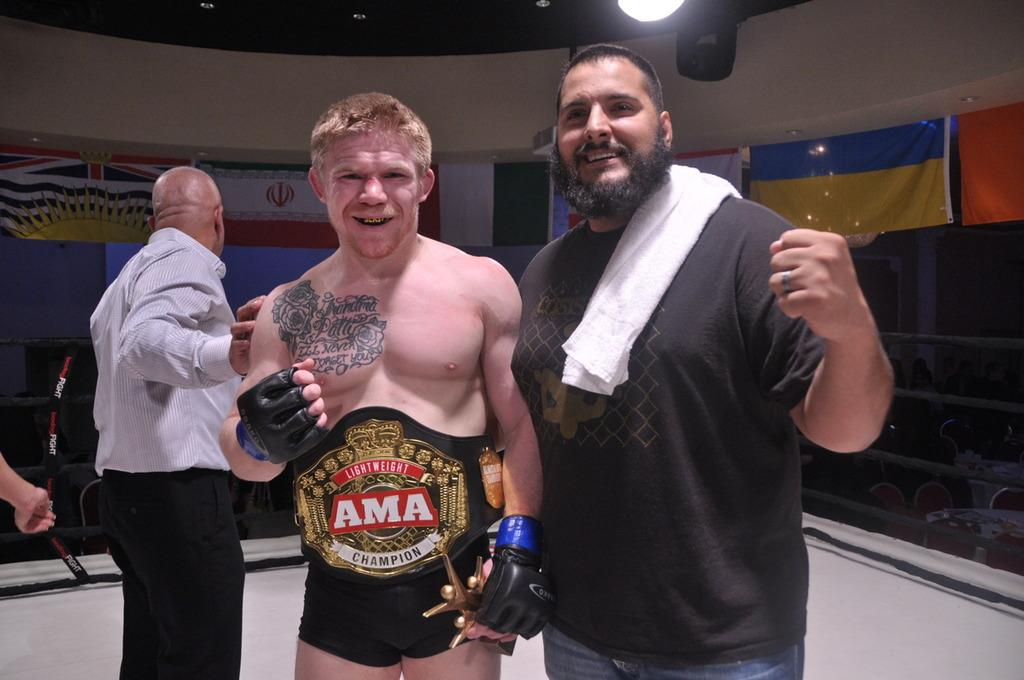<image>
Present a compact description of the photo's key features. Two men posing for a photo while one of them has a belt that has ama  in the middle. 